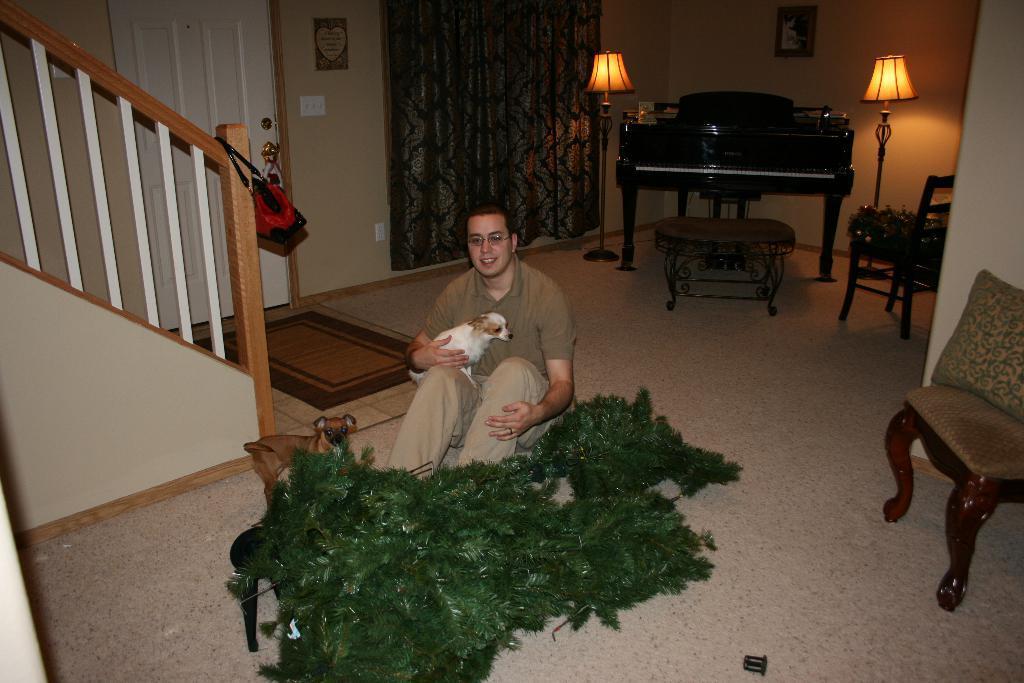In one or two sentences, can you explain what this image depicts? This picture shows a man sitting in the room holding a dog in his hands. Beside him there is another dog. In front of him there are some plants here. In the right side, there is a chair and in the background there is a piano and two lamps. We can observe a photograph attached to the wall and a curtain here. In the right side there is a railing. 